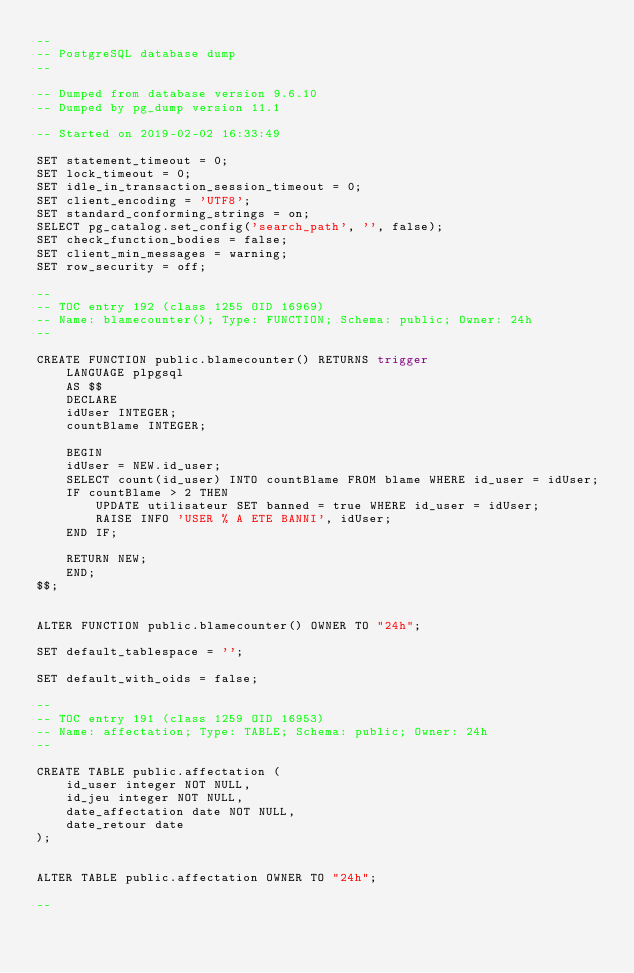<code> <loc_0><loc_0><loc_500><loc_500><_SQL_>--
-- PostgreSQL database dump
--

-- Dumped from database version 9.6.10
-- Dumped by pg_dump version 11.1

-- Started on 2019-02-02 16:33:49

SET statement_timeout = 0;
SET lock_timeout = 0;
SET idle_in_transaction_session_timeout = 0;
SET client_encoding = 'UTF8';
SET standard_conforming_strings = on;
SELECT pg_catalog.set_config('search_path', '', false);
SET check_function_bodies = false;
SET client_min_messages = warning;
SET row_security = off;

--
-- TOC entry 192 (class 1255 OID 16969)
-- Name: blamecounter(); Type: FUNCTION; Schema: public; Owner: 24h
--

CREATE FUNCTION public.blamecounter() RETURNS trigger
    LANGUAGE plpgsql
    AS $$
    DECLARE
    idUser INTEGER; 
    countBlame INTEGER;

    BEGIN
    idUser = NEW.id_user;
    SELECT count(id_user) INTO countBlame FROM blame WHERE id_user = idUser;
    IF countBlame > 2 THEN
        UPDATE utilisateur SET banned = true WHERE id_user = idUser;
        RAISE INFO 'USER % A ETE BANNI', idUser;
    END IF;

    RETURN NEW;
    END;
$$;


ALTER FUNCTION public.blamecounter() OWNER TO "24h";

SET default_tablespace = '';

SET default_with_oids = false;

--
-- TOC entry 191 (class 1259 OID 16953)
-- Name: affectation; Type: TABLE; Schema: public; Owner: 24h
--

CREATE TABLE public.affectation (
    id_user integer NOT NULL,
    id_jeu integer NOT NULL,
    date_affectation date NOT NULL,
    date_retour date
);


ALTER TABLE public.affectation OWNER TO "24h";

--</code> 